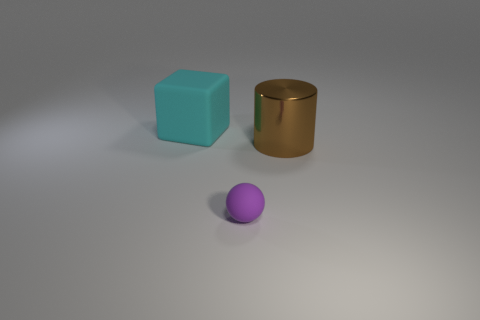Add 2 large matte objects. How many objects exist? 5 Subtract 1 balls. How many balls are left? 0 Subtract all large brown shiny objects. Subtract all metallic cylinders. How many objects are left? 1 Add 1 metallic cylinders. How many metallic cylinders are left? 2 Add 3 yellow rubber blocks. How many yellow rubber blocks exist? 3 Subtract 1 cyan cubes. How many objects are left? 2 Subtract all spheres. How many objects are left? 2 